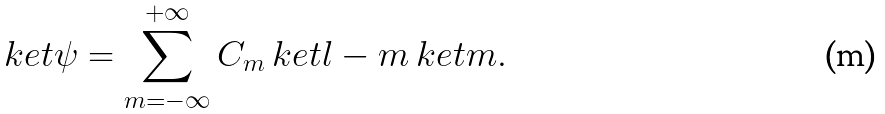Convert formula to latex. <formula><loc_0><loc_0><loc_500><loc_500>\ k e t { \psi } = \sum _ { m = - \infty } ^ { + \infty } C _ { m } \ k e t { l - m } \ k e t { m } .</formula> 